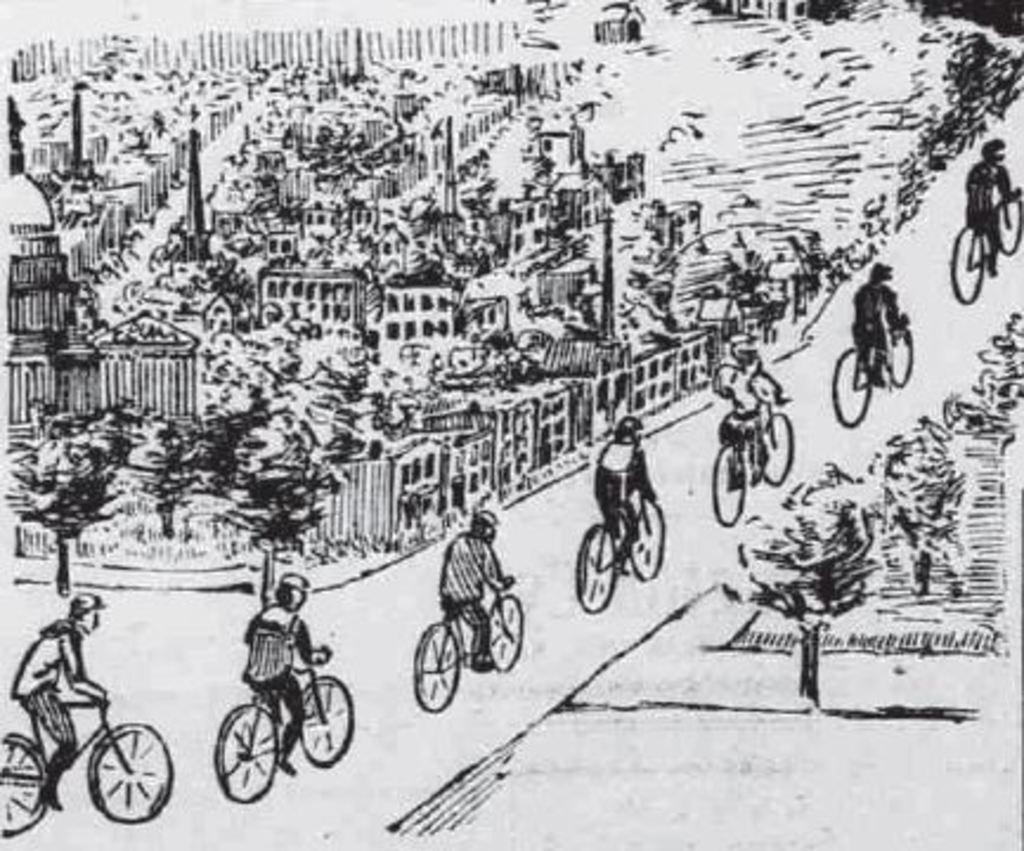What is the main subject of the image? There is an art piece in the image. What are the people in the image doing? People are riding bicycles on the road in the image. What can be seen in the background of the image? There are buildings, trees, and some unspecified objects in the background of the image. How many geese are flying in the sky in the image? There are no geese or sky visible in the image; it features an art piece and people riding bicycles on the road. What is the edge of the image made of? The edge of the image is not made of any material, as it is a digital representation and not a physical object. 